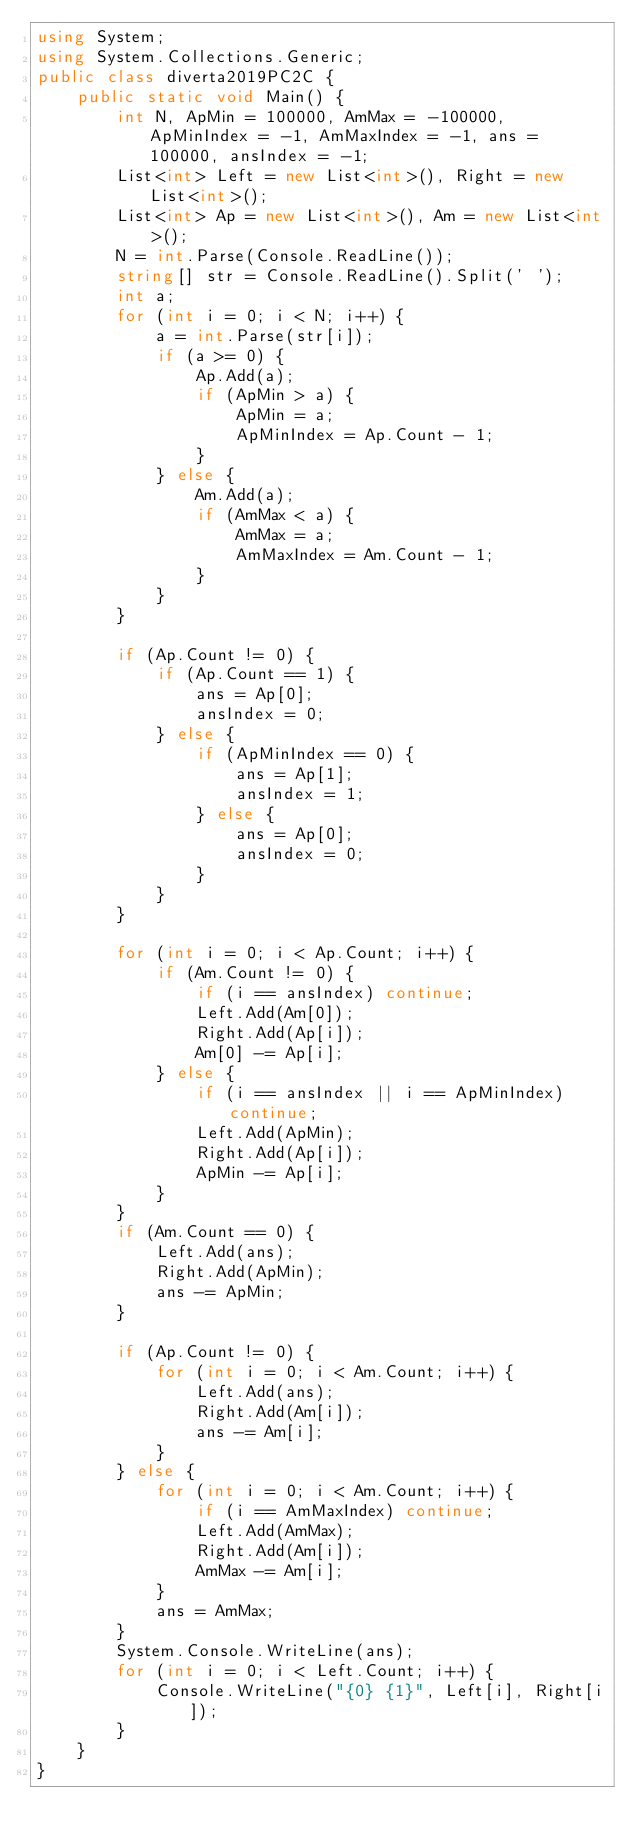<code> <loc_0><loc_0><loc_500><loc_500><_C#_>using System;
using System.Collections.Generic;
public class diverta2019PC2C {
    public static void Main() {
        int N, ApMin = 100000, AmMax = -100000, ApMinIndex = -1, AmMaxIndex = -1, ans = 100000, ansIndex = -1;
        List<int> Left = new List<int>(), Right = new List<int>();
        List<int> Ap = new List<int>(), Am = new List<int>();
        N = int.Parse(Console.ReadLine());
        string[] str = Console.ReadLine().Split(' ');
        int a;
        for (int i = 0; i < N; i++) {
            a = int.Parse(str[i]);
            if (a >= 0) {
                Ap.Add(a);
                if (ApMin > a) {
                    ApMin = a;
                    ApMinIndex = Ap.Count - 1;
                }
            } else {
                Am.Add(a);
                if (AmMax < a) {
                    AmMax = a;
                    AmMaxIndex = Am.Count - 1;
                }
            }
        }

        if (Ap.Count != 0) {
            if (Ap.Count == 1) {
                ans = Ap[0];
                ansIndex = 0;
            } else {
                if (ApMinIndex == 0) {
                    ans = Ap[1];
                    ansIndex = 1;
                } else {
                    ans = Ap[0];
                    ansIndex = 0;
                }
            }
        }

        for (int i = 0; i < Ap.Count; i++) {
            if (Am.Count != 0) {
                if (i == ansIndex) continue;
                Left.Add(Am[0]);
                Right.Add(Ap[i]);
                Am[0] -= Ap[i];
            } else {
                if (i == ansIndex || i == ApMinIndex) continue;
                Left.Add(ApMin);
                Right.Add(Ap[i]);
                ApMin -= Ap[i];
            }
        }
        if (Am.Count == 0) {
            Left.Add(ans);
            Right.Add(ApMin);
            ans -= ApMin;
        }

        if (Ap.Count != 0) {
            for (int i = 0; i < Am.Count; i++) {
                Left.Add(ans);
                Right.Add(Am[i]);
                ans -= Am[i];
            }
        } else {
            for (int i = 0; i < Am.Count; i++) {
                if (i == AmMaxIndex) continue;
                Left.Add(AmMax);
                Right.Add(Am[i]);
                AmMax -= Am[i];
            }
            ans = AmMax;
        }
        System.Console.WriteLine(ans);
        for (int i = 0; i < Left.Count; i++) {
            Console.WriteLine("{0} {1}", Left[i], Right[i]);
        }
    }
}
</code> 